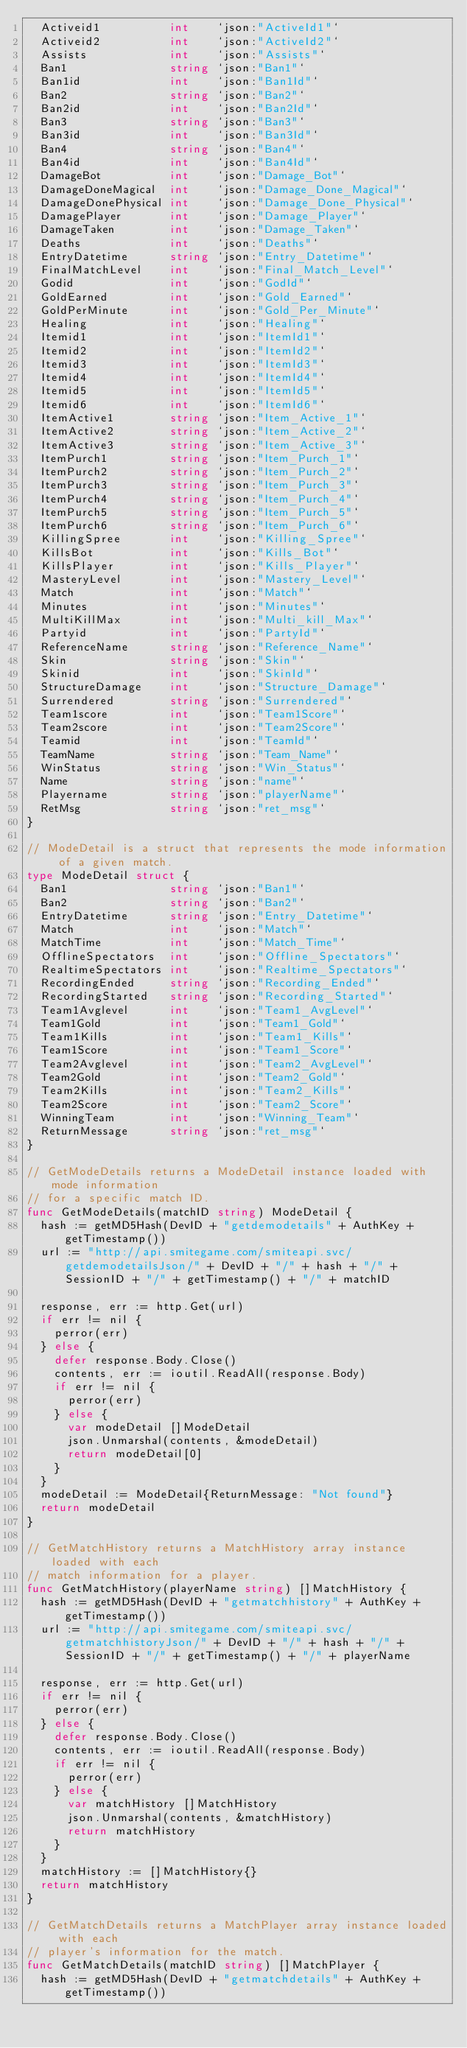Convert code to text. <code><loc_0><loc_0><loc_500><loc_500><_Go_>	Activeid1          int    `json:"ActiveId1"`
	Activeid2          int    `json:"ActiveId2"`
	Assists            int    `json:"Assists"`
	Ban1               string `json:"Ban1"`
	Ban1id             int    `json:"Ban1Id"`
	Ban2               string `json:"Ban2"`
	Ban2id             int    `json:"Ban2Id"`
	Ban3               string `json:"Ban3"`
	Ban3id             int    `json:"Ban3Id"`
	Ban4               string `json:"Ban4"`
	Ban4id             int    `json:"Ban4Id"`
	DamageBot          int    `json:"Damage_Bot"`
	DamageDoneMagical  int    `json:"Damage_Done_Magical"`
	DamageDonePhysical int    `json:"Damage_Done_Physical"`
	DamagePlayer       int    `json:"Damage_Player"`
	DamageTaken        int    `json:"Damage_Taken"`
	Deaths             int    `json:"Deaths"`
	EntryDatetime      string `json:"Entry_Datetime"`
	FinalMatchLevel    int    `json:"Final_Match_Level"`
	Godid              int    `json:"GodId"`
	GoldEarned         int    `json:"Gold_Earned"`
	GoldPerMinute      int    `json:"Gold_Per_Minute"`
	Healing            int    `json:"Healing"`
	Itemid1            int    `json:"ItemId1"`
	Itemid2            int    `json:"ItemId2"`
	Itemid3            int    `json:"ItemId3"`
	Itemid4            int    `json:"ItemId4"`
	Itemid5            int    `json:"ItemId5"`
	Itemid6            int    `json:"ItemId6"`
	ItemActive1        string `json:"Item_Active_1"`
	ItemActive2        string `json:"Item_Active_2"`
	ItemActive3        string `json:"Item_Active_3"`
	ItemPurch1         string `json:"Item_Purch_1"`
	ItemPurch2         string `json:"Item_Purch_2"`
	ItemPurch3         string `json:"Item_Purch_3"`
	ItemPurch4         string `json:"Item_Purch_4"`
	ItemPurch5         string `json:"Item_Purch_5"`
	ItemPurch6         string `json:"Item_Purch_6"`
	KillingSpree       int    `json:"Killing_Spree"`
	KillsBot           int    `json:"Kills_Bot"`
	KillsPlayer        int    `json:"Kills_Player"`
	MasteryLevel       int    `json:"Mastery_Level"`
	Match              int    `json:"Match"`
	Minutes            int    `json:"Minutes"`
	MultiKillMax       int    `json:"Multi_kill_Max"`
	Partyid            int    `json:"PartyId"`
	ReferenceName      string `json:"Reference_Name"`
	Skin               string `json:"Skin"`
	Skinid             int    `json:"SkinId"`
	StructureDamage    int    `json:"Structure_Damage"`
	Surrendered        string `json:"Surrendered"`
	Team1score         int    `json:"Team1Score"`
	Team2score         int    `json:"Team2Score"`
	Teamid             int    `json:"TeamId"`
	TeamName           string `json:"Team_Name"`
	WinStatus          string `json:"Win_Status"`
	Name               string `json:"name"`
	Playername         string `json:"playerName"`
	RetMsg             string `json:"ret_msg"`
}

// ModeDetail is a struct that represents the mode information of a given match.
type ModeDetail struct {
	Ban1               string `json:"Ban1"`
	Ban2               string `json:"Ban2"`
	EntryDatetime      string `json:"Entry_Datetime"`
	Match              int    `json:"Match"`
	MatchTime          int    `json:"Match_Time"`
	OfflineSpectators  int    `json:"Offline_Spectators"`
	RealtimeSpectators int    `json:"Realtime_Spectators"`
	RecordingEnded     string `json:"Recording_Ended"`
	RecordingStarted   string `json:"Recording_Started"`
	Team1Avglevel      int    `json:"Team1_AvgLevel"`
	Team1Gold          int    `json:"Team1_Gold"`
	Team1Kills         int    `json:"Team1_Kills"`
	Team1Score         int    `json:"Team1_Score"`
	Team2Avglevel      int    `json:"Team2_AvgLevel"`
	Team2Gold          int    `json:"Team2_Gold"`
	Team2Kills         int    `json:"Team2_Kills"`
	Team2Score         int    `json:"Team2_Score"`
	WinningTeam        int    `json:"Winning_Team"`
	ReturnMessage      string `json:"ret_msg"`
}

// GetModeDetails returns a ModeDetail instance loaded with mode information
// for a specific match ID.
func GetModeDetails(matchID string) ModeDetail {
	hash := getMD5Hash(DevID + "getdemodetails" + AuthKey + getTimestamp())
	url := "http://api.smitegame.com/smiteapi.svc/getdemodetailsJson/" + DevID + "/" + hash + "/" + SessionID + "/" + getTimestamp() + "/" + matchID

	response, err := http.Get(url)
	if err != nil {
		perror(err)
	} else {
		defer response.Body.Close()
		contents, err := ioutil.ReadAll(response.Body)
		if err != nil {
			perror(err)
		} else {
			var modeDetail []ModeDetail
			json.Unmarshal(contents, &modeDetail)
			return modeDetail[0]
		}
	}
	modeDetail := ModeDetail{ReturnMessage: "Not found"}
	return modeDetail
}

// GetMatchHistory returns a MatchHistory array instance loaded with each
// match information for a player.
func GetMatchHistory(playerName string) []MatchHistory {
	hash := getMD5Hash(DevID + "getmatchhistory" + AuthKey + getTimestamp())
	url := "http://api.smitegame.com/smiteapi.svc/getmatchhistoryJson/" + DevID + "/" + hash + "/" + SessionID + "/" + getTimestamp() + "/" + playerName

	response, err := http.Get(url)
	if err != nil {
		perror(err)
	} else {
		defer response.Body.Close()
		contents, err := ioutil.ReadAll(response.Body)
		if err != nil {
			perror(err)
		} else {
			var matchHistory []MatchHistory
			json.Unmarshal(contents, &matchHistory)
			return matchHistory
		}
	}
	matchHistory := []MatchHistory{}
	return matchHistory
}

// GetMatchDetails returns a MatchPlayer array instance loaded with each
// player's information for the match.
func GetMatchDetails(matchID string) []MatchPlayer {
	hash := getMD5Hash(DevID + "getmatchdetails" + AuthKey + getTimestamp())</code> 